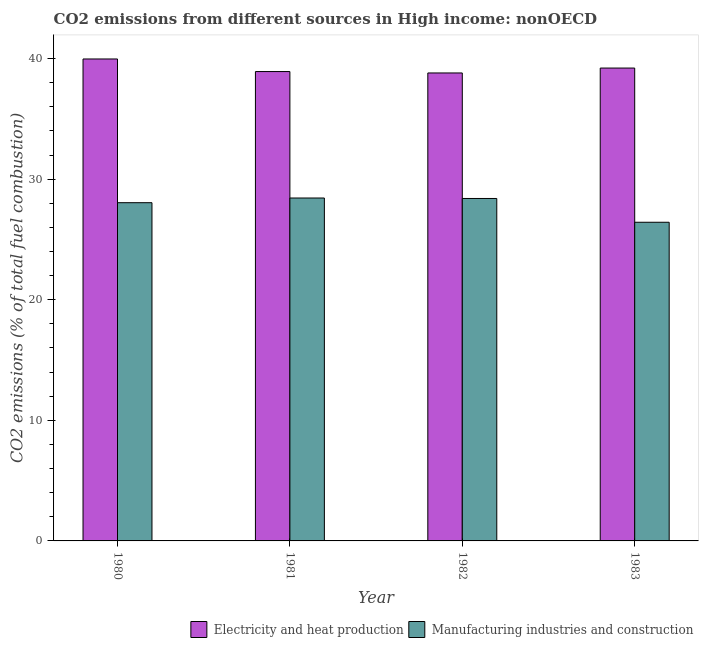How many bars are there on the 1st tick from the left?
Give a very brief answer. 2. How many bars are there on the 4th tick from the right?
Your answer should be compact. 2. In how many cases, is the number of bars for a given year not equal to the number of legend labels?
Your answer should be compact. 0. What is the co2 emissions due to electricity and heat production in 1983?
Your answer should be compact. 39.21. Across all years, what is the maximum co2 emissions due to manufacturing industries?
Your answer should be very brief. 28.44. Across all years, what is the minimum co2 emissions due to electricity and heat production?
Keep it short and to the point. 38.8. In which year was the co2 emissions due to manufacturing industries maximum?
Provide a short and direct response. 1981. In which year was the co2 emissions due to manufacturing industries minimum?
Keep it short and to the point. 1983. What is the total co2 emissions due to electricity and heat production in the graph?
Make the answer very short. 156.9. What is the difference between the co2 emissions due to electricity and heat production in 1980 and that in 1982?
Keep it short and to the point. 1.16. What is the difference between the co2 emissions due to electricity and heat production in 1982 and the co2 emissions due to manufacturing industries in 1980?
Your answer should be very brief. -1.16. What is the average co2 emissions due to manufacturing industries per year?
Provide a succinct answer. 27.83. What is the ratio of the co2 emissions due to electricity and heat production in 1981 to that in 1983?
Give a very brief answer. 0.99. Is the difference between the co2 emissions due to manufacturing industries in 1981 and 1982 greater than the difference between the co2 emissions due to electricity and heat production in 1981 and 1982?
Your response must be concise. No. What is the difference between the highest and the second highest co2 emissions due to manufacturing industries?
Your response must be concise. 0.04. What is the difference between the highest and the lowest co2 emissions due to manufacturing industries?
Make the answer very short. 2.01. In how many years, is the co2 emissions due to manufacturing industries greater than the average co2 emissions due to manufacturing industries taken over all years?
Give a very brief answer. 3. Is the sum of the co2 emissions due to manufacturing industries in 1981 and 1982 greater than the maximum co2 emissions due to electricity and heat production across all years?
Give a very brief answer. Yes. What does the 1st bar from the left in 1982 represents?
Your response must be concise. Electricity and heat production. What does the 2nd bar from the right in 1983 represents?
Offer a terse response. Electricity and heat production. How many bars are there?
Your response must be concise. 8. How many years are there in the graph?
Offer a very short reply. 4. Are the values on the major ticks of Y-axis written in scientific E-notation?
Your answer should be compact. No. Does the graph contain any zero values?
Provide a succinct answer. No. What is the title of the graph?
Offer a very short reply. CO2 emissions from different sources in High income: nonOECD. Does "Primary" appear as one of the legend labels in the graph?
Your answer should be compact. No. What is the label or title of the Y-axis?
Your response must be concise. CO2 emissions (% of total fuel combustion). What is the CO2 emissions (% of total fuel combustion) of Electricity and heat production in 1980?
Make the answer very short. 39.96. What is the CO2 emissions (% of total fuel combustion) in Manufacturing industries and construction in 1980?
Ensure brevity in your answer.  28.05. What is the CO2 emissions (% of total fuel combustion) of Electricity and heat production in 1981?
Your answer should be very brief. 38.92. What is the CO2 emissions (% of total fuel combustion) of Manufacturing industries and construction in 1981?
Offer a terse response. 28.44. What is the CO2 emissions (% of total fuel combustion) of Electricity and heat production in 1982?
Provide a succinct answer. 38.8. What is the CO2 emissions (% of total fuel combustion) in Manufacturing industries and construction in 1982?
Provide a succinct answer. 28.4. What is the CO2 emissions (% of total fuel combustion) of Electricity and heat production in 1983?
Your answer should be compact. 39.21. What is the CO2 emissions (% of total fuel combustion) of Manufacturing industries and construction in 1983?
Give a very brief answer. 26.42. Across all years, what is the maximum CO2 emissions (% of total fuel combustion) in Electricity and heat production?
Your answer should be compact. 39.96. Across all years, what is the maximum CO2 emissions (% of total fuel combustion) of Manufacturing industries and construction?
Make the answer very short. 28.44. Across all years, what is the minimum CO2 emissions (% of total fuel combustion) of Electricity and heat production?
Offer a terse response. 38.8. Across all years, what is the minimum CO2 emissions (% of total fuel combustion) in Manufacturing industries and construction?
Your response must be concise. 26.42. What is the total CO2 emissions (% of total fuel combustion) of Electricity and heat production in the graph?
Provide a succinct answer. 156.9. What is the total CO2 emissions (% of total fuel combustion) of Manufacturing industries and construction in the graph?
Your response must be concise. 111.3. What is the difference between the CO2 emissions (% of total fuel combustion) in Electricity and heat production in 1980 and that in 1981?
Give a very brief answer. 1.04. What is the difference between the CO2 emissions (% of total fuel combustion) of Manufacturing industries and construction in 1980 and that in 1981?
Offer a terse response. -0.39. What is the difference between the CO2 emissions (% of total fuel combustion) of Electricity and heat production in 1980 and that in 1982?
Offer a very short reply. 1.16. What is the difference between the CO2 emissions (% of total fuel combustion) of Manufacturing industries and construction in 1980 and that in 1982?
Provide a short and direct response. -0.35. What is the difference between the CO2 emissions (% of total fuel combustion) of Electricity and heat production in 1980 and that in 1983?
Your response must be concise. 0.75. What is the difference between the CO2 emissions (% of total fuel combustion) in Manufacturing industries and construction in 1980 and that in 1983?
Your response must be concise. 1.62. What is the difference between the CO2 emissions (% of total fuel combustion) of Electricity and heat production in 1981 and that in 1982?
Keep it short and to the point. 0.12. What is the difference between the CO2 emissions (% of total fuel combustion) of Manufacturing industries and construction in 1981 and that in 1982?
Your answer should be compact. 0.04. What is the difference between the CO2 emissions (% of total fuel combustion) of Electricity and heat production in 1981 and that in 1983?
Your answer should be compact. -0.29. What is the difference between the CO2 emissions (% of total fuel combustion) of Manufacturing industries and construction in 1981 and that in 1983?
Your answer should be compact. 2.01. What is the difference between the CO2 emissions (% of total fuel combustion) in Electricity and heat production in 1982 and that in 1983?
Make the answer very short. -0.41. What is the difference between the CO2 emissions (% of total fuel combustion) of Manufacturing industries and construction in 1982 and that in 1983?
Offer a terse response. 1.97. What is the difference between the CO2 emissions (% of total fuel combustion) of Electricity and heat production in 1980 and the CO2 emissions (% of total fuel combustion) of Manufacturing industries and construction in 1981?
Make the answer very short. 11.53. What is the difference between the CO2 emissions (% of total fuel combustion) in Electricity and heat production in 1980 and the CO2 emissions (% of total fuel combustion) in Manufacturing industries and construction in 1982?
Keep it short and to the point. 11.57. What is the difference between the CO2 emissions (% of total fuel combustion) in Electricity and heat production in 1980 and the CO2 emissions (% of total fuel combustion) in Manufacturing industries and construction in 1983?
Your answer should be very brief. 13.54. What is the difference between the CO2 emissions (% of total fuel combustion) in Electricity and heat production in 1981 and the CO2 emissions (% of total fuel combustion) in Manufacturing industries and construction in 1982?
Your answer should be compact. 10.52. What is the difference between the CO2 emissions (% of total fuel combustion) of Electricity and heat production in 1981 and the CO2 emissions (% of total fuel combustion) of Manufacturing industries and construction in 1983?
Keep it short and to the point. 12.5. What is the difference between the CO2 emissions (% of total fuel combustion) of Electricity and heat production in 1982 and the CO2 emissions (% of total fuel combustion) of Manufacturing industries and construction in 1983?
Ensure brevity in your answer.  12.38. What is the average CO2 emissions (% of total fuel combustion) in Electricity and heat production per year?
Make the answer very short. 39.22. What is the average CO2 emissions (% of total fuel combustion) in Manufacturing industries and construction per year?
Offer a very short reply. 27.83. In the year 1980, what is the difference between the CO2 emissions (% of total fuel combustion) of Electricity and heat production and CO2 emissions (% of total fuel combustion) of Manufacturing industries and construction?
Offer a very short reply. 11.92. In the year 1981, what is the difference between the CO2 emissions (% of total fuel combustion) in Electricity and heat production and CO2 emissions (% of total fuel combustion) in Manufacturing industries and construction?
Make the answer very short. 10.49. In the year 1982, what is the difference between the CO2 emissions (% of total fuel combustion) in Electricity and heat production and CO2 emissions (% of total fuel combustion) in Manufacturing industries and construction?
Your answer should be very brief. 10.41. In the year 1983, what is the difference between the CO2 emissions (% of total fuel combustion) of Electricity and heat production and CO2 emissions (% of total fuel combustion) of Manufacturing industries and construction?
Your answer should be very brief. 12.79. What is the ratio of the CO2 emissions (% of total fuel combustion) in Electricity and heat production in 1980 to that in 1981?
Your answer should be very brief. 1.03. What is the ratio of the CO2 emissions (% of total fuel combustion) in Manufacturing industries and construction in 1980 to that in 1981?
Make the answer very short. 0.99. What is the ratio of the CO2 emissions (% of total fuel combustion) of Electricity and heat production in 1980 to that in 1982?
Make the answer very short. 1.03. What is the ratio of the CO2 emissions (% of total fuel combustion) in Electricity and heat production in 1980 to that in 1983?
Offer a very short reply. 1.02. What is the ratio of the CO2 emissions (% of total fuel combustion) in Manufacturing industries and construction in 1980 to that in 1983?
Give a very brief answer. 1.06. What is the ratio of the CO2 emissions (% of total fuel combustion) in Electricity and heat production in 1981 to that in 1982?
Offer a terse response. 1. What is the ratio of the CO2 emissions (% of total fuel combustion) of Manufacturing industries and construction in 1981 to that in 1982?
Ensure brevity in your answer.  1. What is the ratio of the CO2 emissions (% of total fuel combustion) in Manufacturing industries and construction in 1981 to that in 1983?
Make the answer very short. 1.08. What is the ratio of the CO2 emissions (% of total fuel combustion) in Manufacturing industries and construction in 1982 to that in 1983?
Make the answer very short. 1.07. What is the difference between the highest and the second highest CO2 emissions (% of total fuel combustion) of Electricity and heat production?
Give a very brief answer. 0.75. What is the difference between the highest and the second highest CO2 emissions (% of total fuel combustion) in Manufacturing industries and construction?
Make the answer very short. 0.04. What is the difference between the highest and the lowest CO2 emissions (% of total fuel combustion) of Electricity and heat production?
Your answer should be compact. 1.16. What is the difference between the highest and the lowest CO2 emissions (% of total fuel combustion) of Manufacturing industries and construction?
Offer a terse response. 2.01. 